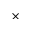<formula> <loc_0><loc_0><loc_500><loc_500>\times</formula> 